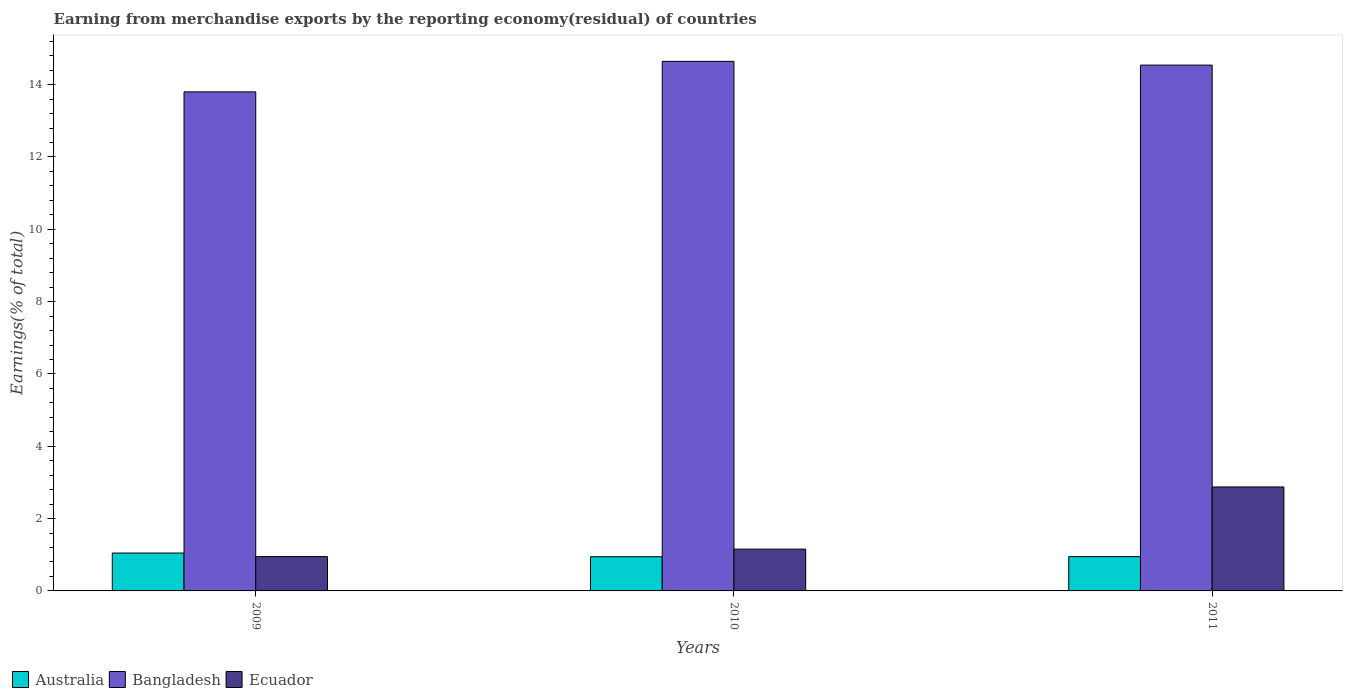How many different coloured bars are there?
Your response must be concise. 3. How many groups of bars are there?
Give a very brief answer. 3. How many bars are there on the 1st tick from the right?
Provide a short and direct response. 3. What is the label of the 2nd group of bars from the left?
Your answer should be very brief. 2010. In how many cases, is the number of bars for a given year not equal to the number of legend labels?
Your answer should be compact. 0. What is the percentage of amount earned from merchandise exports in Bangladesh in 2010?
Provide a succinct answer. 14.64. Across all years, what is the maximum percentage of amount earned from merchandise exports in Australia?
Provide a succinct answer. 1.05. Across all years, what is the minimum percentage of amount earned from merchandise exports in Bangladesh?
Your response must be concise. 13.8. In which year was the percentage of amount earned from merchandise exports in Ecuador minimum?
Provide a succinct answer. 2009. What is the total percentage of amount earned from merchandise exports in Ecuador in the graph?
Your answer should be compact. 4.98. What is the difference between the percentage of amount earned from merchandise exports in Australia in 2009 and that in 2011?
Offer a very short reply. 0.1. What is the difference between the percentage of amount earned from merchandise exports in Bangladesh in 2010 and the percentage of amount earned from merchandise exports in Australia in 2009?
Offer a terse response. 13.6. What is the average percentage of amount earned from merchandise exports in Australia per year?
Provide a short and direct response. 0.98. In the year 2010, what is the difference between the percentage of amount earned from merchandise exports in Ecuador and percentage of amount earned from merchandise exports in Australia?
Offer a terse response. 0.21. What is the ratio of the percentage of amount earned from merchandise exports in Ecuador in 2010 to that in 2011?
Your answer should be compact. 0.4. Is the difference between the percentage of amount earned from merchandise exports in Ecuador in 2009 and 2010 greater than the difference between the percentage of amount earned from merchandise exports in Australia in 2009 and 2010?
Your response must be concise. No. What is the difference between the highest and the second highest percentage of amount earned from merchandise exports in Bangladesh?
Provide a short and direct response. 0.1. What is the difference between the highest and the lowest percentage of amount earned from merchandise exports in Ecuador?
Ensure brevity in your answer.  1.93. In how many years, is the percentage of amount earned from merchandise exports in Bangladesh greater than the average percentage of amount earned from merchandise exports in Bangladesh taken over all years?
Give a very brief answer. 2. Is the sum of the percentage of amount earned from merchandise exports in Australia in 2009 and 2011 greater than the maximum percentage of amount earned from merchandise exports in Ecuador across all years?
Your response must be concise. No. What does the 2nd bar from the left in 2009 represents?
Your answer should be compact. Bangladesh. What is the difference between two consecutive major ticks on the Y-axis?
Offer a very short reply. 2. Are the values on the major ticks of Y-axis written in scientific E-notation?
Your response must be concise. No. How many legend labels are there?
Provide a short and direct response. 3. How are the legend labels stacked?
Provide a succinct answer. Horizontal. What is the title of the graph?
Provide a short and direct response. Earning from merchandise exports by the reporting economy(residual) of countries. Does "Israel" appear as one of the legend labels in the graph?
Your answer should be very brief. No. What is the label or title of the X-axis?
Your answer should be very brief. Years. What is the label or title of the Y-axis?
Your answer should be compact. Earnings(% of total). What is the Earnings(% of total) of Australia in 2009?
Provide a succinct answer. 1.05. What is the Earnings(% of total) of Bangladesh in 2009?
Offer a terse response. 13.8. What is the Earnings(% of total) in Ecuador in 2009?
Your answer should be compact. 0.95. What is the Earnings(% of total) in Australia in 2010?
Ensure brevity in your answer.  0.95. What is the Earnings(% of total) in Bangladesh in 2010?
Provide a short and direct response. 14.64. What is the Earnings(% of total) in Ecuador in 2010?
Give a very brief answer. 1.16. What is the Earnings(% of total) in Australia in 2011?
Provide a succinct answer. 0.95. What is the Earnings(% of total) of Bangladesh in 2011?
Offer a very short reply. 14.54. What is the Earnings(% of total) in Ecuador in 2011?
Provide a succinct answer. 2.88. Across all years, what is the maximum Earnings(% of total) of Australia?
Offer a very short reply. 1.05. Across all years, what is the maximum Earnings(% of total) in Bangladesh?
Offer a terse response. 14.64. Across all years, what is the maximum Earnings(% of total) in Ecuador?
Your answer should be compact. 2.88. Across all years, what is the minimum Earnings(% of total) in Australia?
Provide a succinct answer. 0.95. Across all years, what is the minimum Earnings(% of total) of Bangladesh?
Your answer should be compact. 13.8. Across all years, what is the minimum Earnings(% of total) in Ecuador?
Your answer should be very brief. 0.95. What is the total Earnings(% of total) in Australia in the graph?
Provide a succinct answer. 2.94. What is the total Earnings(% of total) of Bangladesh in the graph?
Offer a very short reply. 42.99. What is the total Earnings(% of total) of Ecuador in the graph?
Provide a short and direct response. 4.98. What is the difference between the Earnings(% of total) in Australia in 2009 and that in 2010?
Offer a very short reply. 0.1. What is the difference between the Earnings(% of total) of Bangladesh in 2009 and that in 2010?
Give a very brief answer. -0.84. What is the difference between the Earnings(% of total) in Ecuador in 2009 and that in 2010?
Ensure brevity in your answer.  -0.21. What is the difference between the Earnings(% of total) of Australia in 2009 and that in 2011?
Your response must be concise. 0.1. What is the difference between the Earnings(% of total) of Bangladesh in 2009 and that in 2011?
Your answer should be compact. -0.74. What is the difference between the Earnings(% of total) in Ecuador in 2009 and that in 2011?
Offer a very short reply. -1.93. What is the difference between the Earnings(% of total) in Australia in 2010 and that in 2011?
Give a very brief answer. -0. What is the difference between the Earnings(% of total) of Bangladesh in 2010 and that in 2011?
Provide a succinct answer. 0.1. What is the difference between the Earnings(% of total) in Ecuador in 2010 and that in 2011?
Your answer should be compact. -1.72. What is the difference between the Earnings(% of total) of Australia in 2009 and the Earnings(% of total) of Bangladesh in 2010?
Ensure brevity in your answer.  -13.6. What is the difference between the Earnings(% of total) of Australia in 2009 and the Earnings(% of total) of Ecuador in 2010?
Provide a succinct answer. -0.11. What is the difference between the Earnings(% of total) in Bangladesh in 2009 and the Earnings(% of total) in Ecuador in 2010?
Provide a short and direct response. 12.64. What is the difference between the Earnings(% of total) in Australia in 2009 and the Earnings(% of total) in Bangladesh in 2011?
Make the answer very short. -13.49. What is the difference between the Earnings(% of total) in Australia in 2009 and the Earnings(% of total) in Ecuador in 2011?
Your answer should be very brief. -1.83. What is the difference between the Earnings(% of total) of Bangladesh in 2009 and the Earnings(% of total) of Ecuador in 2011?
Give a very brief answer. 10.93. What is the difference between the Earnings(% of total) of Australia in 2010 and the Earnings(% of total) of Bangladesh in 2011?
Offer a terse response. -13.59. What is the difference between the Earnings(% of total) in Australia in 2010 and the Earnings(% of total) in Ecuador in 2011?
Provide a short and direct response. -1.93. What is the difference between the Earnings(% of total) of Bangladesh in 2010 and the Earnings(% of total) of Ecuador in 2011?
Offer a terse response. 11.77. What is the average Earnings(% of total) of Australia per year?
Give a very brief answer. 0.98. What is the average Earnings(% of total) in Bangladesh per year?
Your response must be concise. 14.33. What is the average Earnings(% of total) of Ecuador per year?
Offer a terse response. 1.66. In the year 2009, what is the difference between the Earnings(% of total) of Australia and Earnings(% of total) of Bangladesh?
Make the answer very short. -12.75. In the year 2009, what is the difference between the Earnings(% of total) of Australia and Earnings(% of total) of Ecuador?
Provide a short and direct response. 0.1. In the year 2009, what is the difference between the Earnings(% of total) of Bangladesh and Earnings(% of total) of Ecuador?
Give a very brief answer. 12.85. In the year 2010, what is the difference between the Earnings(% of total) of Australia and Earnings(% of total) of Bangladesh?
Provide a succinct answer. -13.7. In the year 2010, what is the difference between the Earnings(% of total) of Australia and Earnings(% of total) of Ecuador?
Provide a succinct answer. -0.21. In the year 2010, what is the difference between the Earnings(% of total) in Bangladesh and Earnings(% of total) in Ecuador?
Offer a very short reply. 13.49. In the year 2011, what is the difference between the Earnings(% of total) of Australia and Earnings(% of total) of Bangladesh?
Give a very brief answer. -13.59. In the year 2011, what is the difference between the Earnings(% of total) of Australia and Earnings(% of total) of Ecuador?
Provide a succinct answer. -1.93. In the year 2011, what is the difference between the Earnings(% of total) in Bangladesh and Earnings(% of total) in Ecuador?
Ensure brevity in your answer.  11.67. What is the ratio of the Earnings(% of total) of Australia in 2009 to that in 2010?
Your response must be concise. 1.11. What is the ratio of the Earnings(% of total) in Bangladesh in 2009 to that in 2010?
Ensure brevity in your answer.  0.94. What is the ratio of the Earnings(% of total) in Ecuador in 2009 to that in 2010?
Provide a short and direct response. 0.82. What is the ratio of the Earnings(% of total) of Australia in 2009 to that in 2011?
Give a very brief answer. 1.1. What is the ratio of the Earnings(% of total) of Bangladesh in 2009 to that in 2011?
Offer a very short reply. 0.95. What is the ratio of the Earnings(% of total) in Ecuador in 2009 to that in 2011?
Ensure brevity in your answer.  0.33. What is the ratio of the Earnings(% of total) of Ecuador in 2010 to that in 2011?
Your answer should be very brief. 0.4. What is the difference between the highest and the second highest Earnings(% of total) in Australia?
Your answer should be very brief. 0.1. What is the difference between the highest and the second highest Earnings(% of total) in Bangladesh?
Your response must be concise. 0.1. What is the difference between the highest and the second highest Earnings(% of total) in Ecuador?
Make the answer very short. 1.72. What is the difference between the highest and the lowest Earnings(% of total) in Australia?
Ensure brevity in your answer.  0.1. What is the difference between the highest and the lowest Earnings(% of total) of Bangladesh?
Your answer should be very brief. 0.84. What is the difference between the highest and the lowest Earnings(% of total) in Ecuador?
Your answer should be compact. 1.93. 